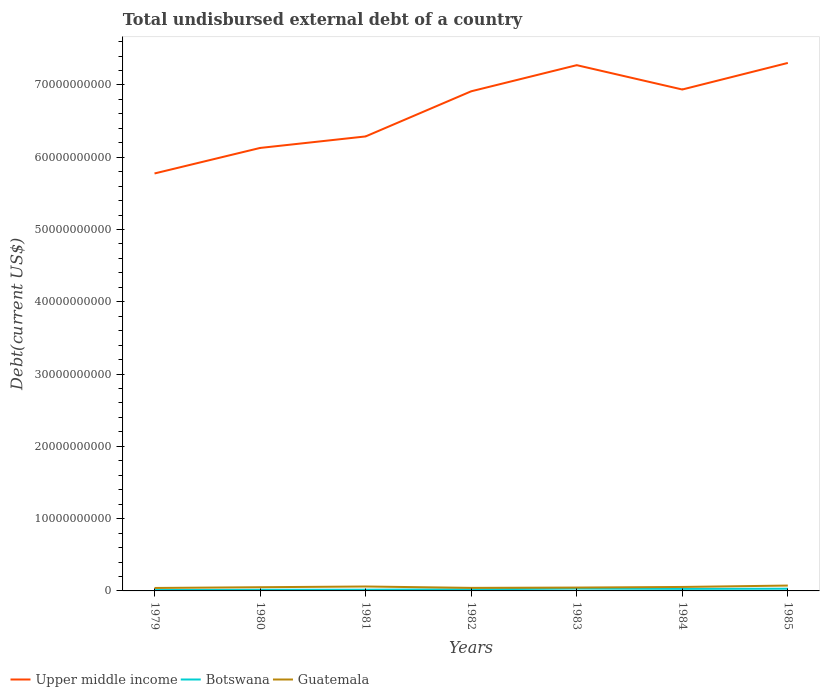How many different coloured lines are there?
Your answer should be very brief. 3. Does the line corresponding to Upper middle income intersect with the line corresponding to Guatemala?
Make the answer very short. No. Is the number of lines equal to the number of legend labels?
Your response must be concise. Yes. Across all years, what is the maximum total undisbursed external debt in Botswana?
Give a very brief answer. 1.18e+08. In which year was the total undisbursed external debt in Upper middle income maximum?
Your answer should be very brief. 1979. What is the total total undisbursed external debt in Upper middle income in the graph?
Provide a succinct answer. -1.02e+1. What is the difference between the highest and the second highest total undisbursed external debt in Guatemala?
Provide a succinct answer. 3.32e+08. What is the difference between the highest and the lowest total undisbursed external debt in Guatemala?
Offer a terse response. 3. Is the total undisbursed external debt in Botswana strictly greater than the total undisbursed external debt in Upper middle income over the years?
Your response must be concise. Yes. How many lines are there?
Your answer should be compact. 3. How many years are there in the graph?
Ensure brevity in your answer.  7. What is the difference between two consecutive major ticks on the Y-axis?
Your answer should be compact. 1.00e+1. Are the values on the major ticks of Y-axis written in scientific E-notation?
Provide a succinct answer. No. Does the graph contain grids?
Offer a very short reply. No. Where does the legend appear in the graph?
Give a very brief answer. Bottom left. How many legend labels are there?
Give a very brief answer. 3. How are the legend labels stacked?
Offer a terse response. Horizontal. What is the title of the graph?
Provide a succinct answer. Total undisbursed external debt of a country. Does "Fiji" appear as one of the legend labels in the graph?
Your answer should be very brief. No. What is the label or title of the Y-axis?
Your answer should be compact. Debt(current US$). What is the Debt(current US$) in Upper middle income in 1979?
Keep it short and to the point. 5.78e+1. What is the Debt(current US$) of Botswana in 1979?
Provide a succinct answer. 1.18e+08. What is the Debt(current US$) of Guatemala in 1979?
Offer a very short reply. 4.09e+08. What is the Debt(current US$) of Upper middle income in 1980?
Your answer should be very brief. 6.13e+1. What is the Debt(current US$) of Botswana in 1980?
Your answer should be very brief. 1.60e+08. What is the Debt(current US$) of Guatemala in 1980?
Keep it short and to the point. 5.12e+08. What is the Debt(current US$) in Upper middle income in 1981?
Offer a very short reply. 6.29e+1. What is the Debt(current US$) of Botswana in 1981?
Keep it short and to the point. 1.69e+08. What is the Debt(current US$) in Guatemala in 1981?
Give a very brief answer. 6.12e+08. What is the Debt(current US$) in Upper middle income in 1982?
Your answer should be very brief. 6.91e+1. What is the Debt(current US$) in Botswana in 1982?
Ensure brevity in your answer.  2.25e+08. What is the Debt(current US$) in Guatemala in 1982?
Offer a terse response. 4.22e+08. What is the Debt(current US$) of Upper middle income in 1983?
Provide a short and direct response. 7.27e+1. What is the Debt(current US$) of Botswana in 1983?
Your answer should be very brief. 3.24e+08. What is the Debt(current US$) in Guatemala in 1983?
Keep it short and to the point. 4.66e+08. What is the Debt(current US$) in Upper middle income in 1984?
Your answer should be very brief. 6.94e+1. What is the Debt(current US$) of Botswana in 1984?
Provide a succinct answer. 2.81e+08. What is the Debt(current US$) in Guatemala in 1984?
Your answer should be compact. 5.49e+08. What is the Debt(current US$) in Upper middle income in 1985?
Your answer should be very brief. 7.30e+1. What is the Debt(current US$) in Botswana in 1985?
Provide a succinct answer. 3.06e+08. What is the Debt(current US$) of Guatemala in 1985?
Provide a short and direct response. 7.41e+08. Across all years, what is the maximum Debt(current US$) of Upper middle income?
Keep it short and to the point. 7.30e+1. Across all years, what is the maximum Debt(current US$) of Botswana?
Give a very brief answer. 3.24e+08. Across all years, what is the maximum Debt(current US$) of Guatemala?
Your answer should be compact. 7.41e+08. Across all years, what is the minimum Debt(current US$) in Upper middle income?
Keep it short and to the point. 5.78e+1. Across all years, what is the minimum Debt(current US$) of Botswana?
Keep it short and to the point. 1.18e+08. Across all years, what is the minimum Debt(current US$) in Guatemala?
Offer a very short reply. 4.09e+08. What is the total Debt(current US$) in Upper middle income in the graph?
Provide a short and direct response. 4.66e+11. What is the total Debt(current US$) in Botswana in the graph?
Give a very brief answer. 1.58e+09. What is the total Debt(current US$) of Guatemala in the graph?
Offer a terse response. 3.71e+09. What is the difference between the Debt(current US$) in Upper middle income in 1979 and that in 1980?
Your answer should be very brief. -3.53e+09. What is the difference between the Debt(current US$) in Botswana in 1979 and that in 1980?
Keep it short and to the point. -4.16e+07. What is the difference between the Debt(current US$) in Guatemala in 1979 and that in 1980?
Your answer should be compact. -1.03e+08. What is the difference between the Debt(current US$) in Upper middle income in 1979 and that in 1981?
Give a very brief answer. -5.12e+09. What is the difference between the Debt(current US$) in Botswana in 1979 and that in 1981?
Your answer should be compact. -5.10e+07. What is the difference between the Debt(current US$) in Guatemala in 1979 and that in 1981?
Provide a succinct answer. -2.03e+08. What is the difference between the Debt(current US$) in Upper middle income in 1979 and that in 1982?
Make the answer very short. -1.14e+1. What is the difference between the Debt(current US$) in Botswana in 1979 and that in 1982?
Offer a terse response. -1.07e+08. What is the difference between the Debt(current US$) in Guatemala in 1979 and that in 1982?
Keep it short and to the point. -1.31e+07. What is the difference between the Debt(current US$) in Upper middle income in 1979 and that in 1983?
Provide a succinct answer. -1.50e+1. What is the difference between the Debt(current US$) of Botswana in 1979 and that in 1983?
Offer a terse response. -2.06e+08. What is the difference between the Debt(current US$) of Guatemala in 1979 and that in 1983?
Offer a very short reply. -5.65e+07. What is the difference between the Debt(current US$) in Upper middle income in 1979 and that in 1984?
Offer a terse response. -1.16e+1. What is the difference between the Debt(current US$) in Botswana in 1979 and that in 1984?
Your answer should be compact. -1.63e+08. What is the difference between the Debt(current US$) of Guatemala in 1979 and that in 1984?
Your answer should be very brief. -1.40e+08. What is the difference between the Debt(current US$) in Upper middle income in 1979 and that in 1985?
Your answer should be compact. -1.53e+1. What is the difference between the Debt(current US$) of Botswana in 1979 and that in 1985?
Offer a terse response. -1.88e+08. What is the difference between the Debt(current US$) of Guatemala in 1979 and that in 1985?
Ensure brevity in your answer.  -3.32e+08. What is the difference between the Debt(current US$) of Upper middle income in 1980 and that in 1981?
Offer a terse response. -1.59e+09. What is the difference between the Debt(current US$) in Botswana in 1980 and that in 1981?
Make the answer very short. -9.33e+06. What is the difference between the Debt(current US$) in Guatemala in 1980 and that in 1981?
Provide a succinct answer. -1.01e+08. What is the difference between the Debt(current US$) of Upper middle income in 1980 and that in 1982?
Your response must be concise. -7.84e+09. What is the difference between the Debt(current US$) of Botswana in 1980 and that in 1982?
Your answer should be compact. -6.54e+07. What is the difference between the Debt(current US$) of Guatemala in 1980 and that in 1982?
Make the answer very short. 8.94e+07. What is the difference between the Debt(current US$) in Upper middle income in 1980 and that in 1983?
Your answer should be compact. -1.15e+1. What is the difference between the Debt(current US$) of Botswana in 1980 and that in 1983?
Your answer should be compact. -1.65e+08. What is the difference between the Debt(current US$) in Guatemala in 1980 and that in 1983?
Give a very brief answer. 4.60e+07. What is the difference between the Debt(current US$) of Upper middle income in 1980 and that in 1984?
Provide a succinct answer. -8.09e+09. What is the difference between the Debt(current US$) of Botswana in 1980 and that in 1984?
Your answer should be very brief. -1.22e+08. What is the difference between the Debt(current US$) of Guatemala in 1980 and that in 1984?
Ensure brevity in your answer.  -3.72e+07. What is the difference between the Debt(current US$) of Upper middle income in 1980 and that in 1985?
Your answer should be compact. -1.18e+1. What is the difference between the Debt(current US$) of Botswana in 1980 and that in 1985?
Your answer should be compact. -1.46e+08. What is the difference between the Debt(current US$) in Guatemala in 1980 and that in 1985?
Your answer should be very brief. -2.30e+08. What is the difference between the Debt(current US$) of Upper middle income in 1981 and that in 1982?
Your answer should be very brief. -6.24e+09. What is the difference between the Debt(current US$) in Botswana in 1981 and that in 1982?
Your response must be concise. -5.61e+07. What is the difference between the Debt(current US$) in Guatemala in 1981 and that in 1982?
Keep it short and to the point. 1.90e+08. What is the difference between the Debt(current US$) of Upper middle income in 1981 and that in 1983?
Your response must be concise. -9.86e+09. What is the difference between the Debt(current US$) in Botswana in 1981 and that in 1983?
Offer a very short reply. -1.55e+08. What is the difference between the Debt(current US$) of Guatemala in 1981 and that in 1983?
Make the answer very short. 1.47e+08. What is the difference between the Debt(current US$) of Upper middle income in 1981 and that in 1984?
Your answer should be compact. -6.49e+09. What is the difference between the Debt(current US$) of Botswana in 1981 and that in 1984?
Make the answer very short. -1.12e+08. What is the difference between the Debt(current US$) in Guatemala in 1981 and that in 1984?
Offer a very short reply. 6.34e+07. What is the difference between the Debt(current US$) in Upper middle income in 1981 and that in 1985?
Provide a succinct answer. -1.02e+1. What is the difference between the Debt(current US$) in Botswana in 1981 and that in 1985?
Keep it short and to the point. -1.37e+08. What is the difference between the Debt(current US$) in Guatemala in 1981 and that in 1985?
Offer a very short reply. -1.29e+08. What is the difference between the Debt(current US$) in Upper middle income in 1982 and that in 1983?
Ensure brevity in your answer.  -3.62e+09. What is the difference between the Debt(current US$) of Botswana in 1982 and that in 1983?
Offer a very short reply. -9.93e+07. What is the difference between the Debt(current US$) of Guatemala in 1982 and that in 1983?
Keep it short and to the point. -4.34e+07. What is the difference between the Debt(current US$) of Upper middle income in 1982 and that in 1984?
Make the answer very short. -2.49e+08. What is the difference between the Debt(current US$) of Botswana in 1982 and that in 1984?
Give a very brief answer. -5.63e+07. What is the difference between the Debt(current US$) in Guatemala in 1982 and that in 1984?
Your answer should be compact. -1.27e+08. What is the difference between the Debt(current US$) in Upper middle income in 1982 and that in 1985?
Provide a succinct answer. -3.92e+09. What is the difference between the Debt(current US$) in Botswana in 1982 and that in 1985?
Offer a very short reply. -8.07e+07. What is the difference between the Debt(current US$) of Guatemala in 1982 and that in 1985?
Keep it short and to the point. -3.19e+08. What is the difference between the Debt(current US$) of Upper middle income in 1983 and that in 1984?
Make the answer very short. 3.37e+09. What is the difference between the Debt(current US$) in Botswana in 1983 and that in 1984?
Offer a very short reply. 4.31e+07. What is the difference between the Debt(current US$) in Guatemala in 1983 and that in 1984?
Offer a terse response. -8.32e+07. What is the difference between the Debt(current US$) in Upper middle income in 1983 and that in 1985?
Provide a succinct answer. -3.09e+08. What is the difference between the Debt(current US$) of Botswana in 1983 and that in 1985?
Offer a terse response. 1.86e+07. What is the difference between the Debt(current US$) in Guatemala in 1983 and that in 1985?
Provide a succinct answer. -2.76e+08. What is the difference between the Debt(current US$) in Upper middle income in 1984 and that in 1985?
Offer a terse response. -3.68e+09. What is the difference between the Debt(current US$) of Botswana in 1984 and that in 1985?
Offer a very short reply. -2.45e+07. What is the difference between the Debt(current US$) in Guatemala in 1984 and that in 1985?
Your answer should be very brief. -1.92e+08. What is the difference between the Debt(current US$) in Upper middle income in 1979 and the Debt(current US$) in Botswana in 1980?
Your answer should be very brief. 5.76e+1. What is the difference between the Debt(current US$) in Upper middle income in 1979 and the Debt(current US$) in Guatemala in 1980?
Provide a short and direct response. 5.72e+1. What is the difference between the Debt(current US$) in Botswana in 1979 and the Debt(current US$) in Guatemala in 1980?
Keep it short and to the point. -3.94e+08. What is the difference between the Debt(current US$) of Upper middle income in 1979 and the Debt(current US$) of Botswana in 1981?
Your answer should be compact. 5.76e+1. What is the difference between the Debt(current US$) in Upper middle income in 1979 and the Debt(current US$) in Guatemala in 1981?
Offer a very short reply. 5.71e+1. What is the difference between the Debt(current US$) of Botswana in 1979 and the Debt(current US$) of Guatemala in 1981?
Your response must be concise. -4.94e+08. What is the difference between the Debt(current US$) of Upper middle income in 1979 and the Debt(current US$) of Botswana in 1982?
Your answer should be compact. 5.75e+1. What is the difference between the Debt(current US$) in Upper middle income in 1979 and the Debt(current US$) in Guatemala in 1982?
Offer a very short reply. 5.73e+1. What is the difference between the Debt(current US$) in Botswana in 1979 and the Debt(current US$) in Guatemala in 1982?
Give a very brief answer. -3.04e+08. What is the difference between the Debt(current US$) of Upper middle income in 1979 and the Debt(current US$) of Botswana in 1983?
Provide a succinct answer. 5.74e+1. What is the difference between the Debt(current US$) of Upper middle income in 1979 and the Debt(current US$) of Guatemala in 1983?
Give a very brief answer. 5.73e+1. What is the difference between the Debt(current US$) of Botswana in 1979 and the Debt(current US$) of Guatemala in 1983?
Keep it short and to the point. -3.48e+08. What is the difference between the Debt(current US$) of Upper middle income in 1979 and the Debt(current US$) of Botswana in 1984?
Your answer should be compact. 5.75e+1. What is the difference between the Debt(current US$) of Upper middle income in 1979 and the Debt(current US$) of Guatemala in 1984?
Offer a terse response. 5.72e+1. What is the difference between the Debt(current US$) of Botswana in 1979 and the Debt(current US$) of Guatemala in 1984?
Your answer should be compact. -4.31e+08. What is the difference between the Debt(current US$) in Upper middle income in 1979 and the Debt(current US$) in Botswana in 1985?
Provide a succinct answer. 5.74e+1. What is the difference between the Debt(current US$) of Upper middle income in 1979 and the Debt(current US$) of Guatemala in 1985?
Provide a succinct answer. 5.70e+1. What is the difference between the Debt(current US$) in Botswana in 1979 and the Debt(current US$) in Guatemala in 1985?
Make the answer very short. -6.23e+08. What is the difference between the Debt(current US$) in Upper middle income in 1980 and the Debt(current US$) in Botswana in 1981?
Your answer should be compact. 6.11e+1. What is the difference between the Debt(current US$) of Upper middle income in 1980 and the Debt(current US$) of Guatemala in 1981?
Offer a terse response. 6.07e+1. What is the difference between the Debt(current US$) of Botswana in 1980 and the Debt(current US$) of Guatemala in 1981?
Your answer should be compact. -4.53e+08. What is the difference between the Debt(current US$) in Upper middle income in 1980 and the Debt(current US$) in Botswana in 1982?
Keep it short and to the point. 6.11e+1. What is the difference between the Debt(current US$) in Upper middle income in 1980 and the Debt(current US$) in Guatemala in 1982?
Your answer should be compact. 6.09e+1. What is the difference between the Debt(current US$) in Botswana in 1980 and the Debt(current US$) in Guatemala in 1982?
Your answer should be very brief. -2.63e+08. What is the difference between the Debt(current US$) of Upper middle income in 1980 and the Debt(current US$) of Botswana in 1983?
Make the answer very short. 6.10e+1. What is the difference between the Debt(current US$) in Upper middle income in 1980 and the Debt(current US$) in Guatemala in 1983?
Your answer should be compact. 6.08e+1. What is the difference between the Debt(current US$) of Botswana in 1980 and the Debt(current US$) of Guatemala in 1983?
Your answer should be compact. -3.06e+08. What is the difference between the Debt(current US$) of Upper middle income in 1980 and the Debt(current US$) of Botswana in 1984?
Your answer should be very brief. 6.10e+1. What is the difference between the Debt(current US$) of Upper middle income in 1980 and the Debt(current US$) of Guatemala in 1984?
Offer a terse response. 6.07e+1. What is the difference between the Debt(current US$) in Botswana in 1980 and the Debt(current US$) in Guatemala in 1984?
Provide a succinct answer. -3.89e+08. What is the difference between the Debt(current US$) of Upper middle income in 1980 and the Debt(current US$) of Botswana in 1985?
Make the answer very short. 6.10e+1. What is the difference between the Debt(current US$) of Upper middle income in 1980 and the Debt(current US$) of Guatemala in 1985?
Give a very brief answer. 6.05e+1. What is the difference between the Debt(current US$) of Botswana in 1980 and the Debt(current US$) of Guatemala in 1985?
Offer a very short reply. -5.82e+08. What is the difference between the Debt(current US$) in Upper middle income in 1981 and the Debt(current US$) in Botswana in 1982?
Offer a very short reply. 6.27e+1. What is the difference between the Debt(current US$) in Upper middle income in 1981 and the Debt(current US$) in Guatemala in 1982?
Your response must be concise. 6.25e+1. What is the difference between the Debt(current US$) in Botswana in 1981 and the Debt(current US$) in Guatemala in 1982?
Your answer should be compact. -2.53e+08. What is the difference between the Debt(current US$) of Upper middle income in 1981 and the Debt(current US$) of Botswana in 1983?
Make the answer very short. 6.26e+1. What is the difference between the Debt(current US$) of Upper middle income in 1981 and the Debt(current US$) of Guatemala in 1983?
Make the answer very short. 6.24e+1. What is the difference between the Debt(current US$) in Botswana in 1981 and the Debt(current US$) in Guatemala in 1983?
Make the answer very short. -2.97e+08. What is the difference between the Debt(current US$) of Upper middle income in 1981 and the Debt(current US$) of Botswana in 1984?
Keep it short and to the point. 6.26e+1. What is the difference between the Debt(current US$) in Upper middle income in 1981 and the Debt(current US$) in Guatemala in 1984?
Ensure brevity in your answer.  6.23e+1. What is the difference between the Debt(current US$) of Botswana in 1981 and the Debt(current US$) of Guatemala in 1984?
Provide a short and direct response. -3.80e+08. What is the difference between the Debt(current US$) in Upper middle income in 1981 and the Debt(current US$) in Botswana in 1985?
Your answer should be compact. 6.26e+1. What is the difference between the Debt(current US$) in Upper middle income in 1981 and the Debt(current US$) in Guatemala in 1985?
Ensure brevity in your answer.  6.21e+1. What is the difference between the Debt(current US$) of Botswana in 1981 and the Debt(current US$) of Guatemala in 1985?
Provide a succinct answer. -5.72e+08. What is the difference between the Debt(current US$) of Upper middle income in 1982 and the Debt(current US$) of Botswana in 1983?
Offer a terse response. 6.88e+1. What is the difference between the Debt(current US$) of Upper middle income in 1982 and the Debt(current US$) of Guatemala in 1983?
Offer a very short reply. 6.87e+1. What is the difference between the Debt(current US$) in Botswana in 1982 and the Debt(current US$) in Guatemala in 1983?
Give a very brief answer. -2.41e+08. What is the difference between the Debt(current US$) in Upper middle income in 1982 and the Debt(current US$) in Botswana in 1984?
Your answer should be compact. 6.88e+1. What is the difference between the Debt(current US$) of Upper middle income in 1982 and the Debt(current US$) of Guatemala in 1984?
Your answer should be very brief. 6.86e+1. What is the difference between the Debt(current US$) of Botswana in 1982 and the Debt(current US$) of Guatemala in 1984?
Provide a short and direct response. -3.24e+08. What is the difference between the Debt(current US$) of Upper middle income in 1982 and the Debt(current US$) of Botswana in 1985?
Give a very brief answer. 6.88e+1. What is the difference between the Debt(current US$) of Upper middle income in 1982 and the Debt(current US$) of Guatemala in 1985?
Make the answer very short. 6.84e+1. What is the difference between the Debt(current US$) in Botswana in 1982 and the Debt(current US$) in Guatemala in 1985?
Offer a very short reply. -5.16e+08. What is the difference between the Debt(current US$) in Upper middle income in 1983 and the Debt(current US$) in Botswana in 1984?
Offer a very short reply. 7.25e+1. What is the difference between the Debt(current US$) of Upper middle income in 1983 and the Debt(current US$) of Guatemala in 1984?
Make the answer very short. 7.22e+1. What is the difference between the Debt(current US$) of Botswana in 1983 and the Debt(current US$) of Guatemala in 1984?
Provide a succinct answer. -2.24e+08. What is the difference between the Debt(current US$) of Upper middle income in 1983 and the Debt(current US$) of Botswana in 1985?
Make the answer very short. 7.24e+1. What is the difference between the Debt(current US$) in Upper middle income in 1983 and the Debt(current US$) in Guatemala in 1985?
Offer a terse response. 7.20e+1. What is the difference between the Debt(current US$) of Botswana in 1983 and the Debt(current US$) of Guatemala in 1985?
Give a very brief answer. -4.17e+08. What is the difference between the Debt(current US$) of Upper middle income in 1984 and the Debt(current US$) of Botswana in 1985?
Ensure brevity in your answer.  6.91e+1. What is the difference between the Debt(current US$) of Upper middle income in 1984 and the Debt(current US$) of Guatemala in 1985?
Ensure brevity in your answer.  6.86e+1. What is the difference between the Debt(current US$) in Botswana in 1984 and the Debt(current US$) in Guatemala in 1985?
Your response must be concise. -4.60e+08. What is the average Debt(current US$) in Upper middle income per year?
Your answer should be compact. 6.66e+1. What is the average Debt(current US$) of Botswana per year?
Keep it short and to the point. 2.26e+08. What is the average Debt(current US$) in Guatemala per year?
Give a very brief answer. 5.30e+08. In the year 1979, what is the difference between the Debt(current US$) of Upper middle income and Debt(current US$) of Botswana?
Offer a very short reply. 5.76e+1. In the year 1979, what is the difference between the Debt(current US$) of Upper middle income and Debt(current US$) of Guatemala?
Your answer should be compact. 5.73e+1. In the year 1979, what is the difference between the Debt(current US$) of Botswana and Debt(current US$) of Guatemala?
Your response must be concise. -2.91e+08. In the year 1980, what is the difference between the Debt(current US$) in Upper middle income and Debt(current US$) in Botswana?
Your answer should be very brief. 6.11e+1. In the year 1980, what is the difference between the Debt(current US$) in Upper middle income and Debt(current US$) in Guatemala?
Your response must be concise. 6.08e+1. In the year 1980, what is the difference between the Debt(current US$) of Botswana and Debt(current US$) of Guatemala?
Provide a short and direct response. -3.52e+08. In the year 1981, what is the difference between the Debt(current US$) of Upper middle income and Debt(current US$) of Botswana?
Give a very brief answer. 6.27e+1. In the year 1981, what is the difference between the Debt(current US$) in Upper middle income and Debt(current US$) in Guatemala?
Keep it short and to the point. 6.23e+1. In the year 1981, what is the difference between the Debt(current US$) in Botswana and Debt(current US$) in Guatemala?
Give a very brief answer. -4.43e+08. In the year 1982, what is the difference between the Debt(current US$) of Upper middle income and Debt(current US$) of Botswana?
Keep it short and to the point. 6.89e+1. In the year 1982, what is the difference between the Debt(current US$) in Upper middle income and Debt(current US$) in Guatemala?
Your answer should be compact. 6.87e+1. In the year 1982, what is the difference between the Debt(current US$) in Botswana and Debt(current US$) in Guatemala?
Offer a very short reply. -1.97e+08. In the year 1983, what is the difference between the Debt(current US$) of Upper middle income and Debt(current US$) of Botswana?
Ensure brevity in your answer.  7.24e+1. In the year 1983, what is the difference between the Debt(current US$) in Upper middle income and Debt(current US$) in Guatemala?
Your response must be concise. 7.23e+1. In the year 1983, what is the difference between the Debt(current US$) of Botswana and Debt(current US$) of Guatemala?
Make the answer very short. -1.41e+08. In the year 1984, what is the difference between the Debt(current US$) of Upper middle income and Debt(current US$) of Botswana?
Ensure brevity in your answer.  6.91e+1. In the year 1984, what is the difference between the Debt(current US$) of Upper middle income and Debt(current US$) of Guatemala?
Your answer should be very brief. 6.88e+1. In the year 1984, what is the difference between the Debt(current US$) in Botswana and Debt(current US$) in Guatemala?
Your answer should be compact. -2.67e+08. In the year 1985, what is the difference between the Debt(current US$) of Upper middle income and Debt(current US$) of Botswana?
Your answer should be very brief. 7.27e+1. In the year 1985, what is the difference between the Debt(current US$) of Upper middle income and Debt(current US$) of Guatemala?
Provide a short and direct response. 7.23e+1. In the year 1985, what is the difference between the Debt(current US$) in Botswana and Debt(current US$) in Guatemala?
Make the answer very short. -4.35e+08. What is the ratio of the Debt(current US$) in Upper middle income in 1979 to that in 1980?
Offer a terse response. 0.94. What is the ratio of the Debt(current US$) in Botswana in 1979 to that in 1980?
Offer a very short reply. 0.74. What is the ratio of the Debt(current US$) of Guatemala in 1979 to that in 1980?
Ensure brevity in your answer.  0.8. What is the ratio of the Debt(current US$) of Upper middle income in 1979 to that in 1981?
Offer a very short reply. 0.92. What is the ratio of the Debt(current US$) of Botswana in 1979 to that in 1981?
Ensure brevity in your answer.  0.7. What is the ratio of the Debt(current US$) of Guatemala in 1979 to that in 1981?
Provide a succinct answer. 0.67. What is the ratio of the Debt(current US$) in Upper middle income in 1979 to that in 1982?
Offer a very short reply. 0.84. What is the ratio of the Debt(current US$) in Botswana in 1979 to that in 1982?
Your response must be concise. 0.52. What is the ratio of the Debt(current US$) in Guatemala in 1979 to that in 1982?
Provide a succinct answer. 0.97. What is the ratio of the Debt(current US$) in Upper middle income in 1979 to that in 1983?
Ensure brevity in your answer.  0.79. What is the ratio of the Debt(current US$) of Botswana in 1979 to that in 1983?
Provide a succinct answer. 0.36. What is the ratio of the Debt(current US$) of Guatemala in 1979 to that in 1983?
Offer a terse response. 0.88. What is the ratio of the Debt(current US$) in Upper middle income in 1979 to that in 1984?
Keep it short and to the point. 0.83. What is the ratio of the Debt(current US$) in Botswana in 1979 to that in 1984?
Offer a very short reply. 0.42. What is the ratio of the Debt(current US$) of Guatemala in 1979 to that in 1984?
Provide a short and direct response. 0.75. What is the ratio of the Debt(current US$) in Upper middle income in 1979 to that in 1985?
Your response must be concise. 0.79. What is the ratio of the Debt(current US$) of Botswana in 1979 to that in 1985?
Provide a succinct answer. 0.39. What is the ratio of the Debt(current US$) of Guatemala in 1979 to that in 1985?
Ensure brevity in your answer.  0.55. What is the ratio of the Debt(current US$) in Upper middle income in 1980 to that in 1981?
Your response must be concise. 0.97. What is the ratio of the Debt(current US$) in Botswana in 1980 to that in 1981?
Provide a succinct answer. 0.94. What is the ratio of the Debt(current US$) of Guatemala in 1980 to that in 1981?
Make the answer very short. 0.84. What is the ratio of the Debt(current US$) of Upper middle income in 1980 to that in 1982?
Keep it short and to the point. 0.89. What is the ratio of the Debt(current US$) of Botswana in 1980 to that in 1982?
Ensure brevity in your answer.  0.71. What is the ratio of the Debt(current US$) of Guatemala in 1980 to that in 1982?
Offer a terse response. 1.21. What is the ratio of the Debt(current US$) in Upper middle income in 1980 to that in 1983?
Offer a terse response. 0.84. What is the ratio of the Debt(current US$) of Botswana in 1980 to that in 1983?
Your response must be concise. 0.49. What is the ratio of the Debt(current US$) in Guatemala in 1980 to that in 1983?
Your answer should be very brief. 1.1. What is the ratio of the Debt(current US$) of Upper middle income in 1980 to that in 1984?
Make the answer very short. 0.88. What is the ratio of the Debt(current US$) of Botswana in 1980 to that in 1984?
Provide a short and direct response. 0.57. What is the ratio of the Debt(current US$) of Guatemala in 1980 to that in 1984?
Give a very brief answer. 0.93. What is the ratio of the Debt(current US$) in Upper middle income in 1980 to that in 1985?
Your response must be concise. 0.84. What is the ratio of the Debt(current US$) in Botswana in 1980 to that in 1985?
Your answer should be compact. 0.52. What is the ratio of the Debt(current US$) in Guatemala in 1980 to that in 1985?
Your answer should be compact. 0.69. What is the ratio of the Debt(current US$) in Upper middle income in 1981 to that in 1982?
Provide a short and direct response. 0.91. What is the ratio of the Debt(current US$) in Botswana in 1981 to that in 1982?
Ensure brevity in your answer.  0.75. What is the ratio of the Debt(current US$) of Guatemala in 1981 to that in 1982?
Your answer should be compact. 1.45. What is the ratio of the Debt(current US$) of Upper middle income in 1981 to that in 1983?
Offer a terse response. 0.86. What is the ratio of the Debt(current US$) in Botswana in 1981 to that in 1983?
Provide a short and direct response. 0.52. What is the ratio of the Debt(current US$) of Guatemala in 1981 to that in 1983?
Your answer should be compact. 1.31. What is the ratio of the Debt(current US$) of Upper middle income in 1981 to that in 1984?
Your answer should be compact. 0.91. What is the ratio of the Debt(current US$) of Botswana in 1981 to that in 1984?
Keep it short and to the point. 0.6. What is the ratio of the Debt(current US$) in Guatemala in 1981 to that in 1984?
Offer a very short reply. 1.12. What is the ratio of the Debt(current US$) in Upper middle income in 1981 to that in 1985?
Your answer should be very brief. 0.86. What is the ratio of the Debt(current US$) of Botswana in 1981 to that in 1985?
Your answer should be compact. 0.55. What is the ratio of the Debt(current US$) of Guatemala in 1981 to that in 1985?
Your answer should be compact. 0.83. What is the ratio of the Debt(current US$) in Upper middle income in 1982 to that in 1983?
Provide a succinct answer. 0.95. What is the ratio of the Debt(current US$) in Botswana in 1982 to that in 1983?
Your answer should be very brief. 0.69. What is the ratio of the Debt(current US$) of Guatemala in 1982 to that in 1983?
Your response must be concise. 0.91. What is the ratio of the Debt(current US$) in Botswana in 1982 to that in 1984?
Offer a terse response. 0.8. What is the ratio of the Debt(current US$) of Guatemala in 1982 to that in 1984?
Offer a very short reply. 0.77. What is the ratio of the Debt(current US$) in Upper middle income in 1982 to that in 1985?
Your answer should be very brief. 0.95. What is the ratio of the Debt(current US$) of Botswana in 1982 to that in 1985?
Your answer should be compact. 0.74. What is the ratio of the Debt(current US$) in Guatemala in 1982 to that in 1985?
Give a very brief answer. 0.57. What is the ratio of the Debt(current US$) in Upper middle income in 1983 to that in 1984?
Your answer should be very brief. 1.05. What is the ratio of the Debt(current US$) in Botswana in 1983 to that in 1984?
Provide a succinct answer. 1.15. What is the ratio of the Debt(current US$) in Guatemala in 1983 to that in 1984?
Keep it short and to the point. 0.85. What is the ratio of the Debt(current US$) in Upper middle income in 1983 to that in 1985?
Provide a succinct answer. 1. What is the ratio of the Debt(current US$) of Botswana in 1983 to that in 1985?
Offer a very short reply. 1.06. What is the ratio of the Debt(current US$) of Guatemala in 1983 to that in 1985?
Provide a short and direct response. 0.63. What is the ratio of the Debt(current US$) in Upper middle income in 1984 to that in 1985?
Offer a terse response. 0.95. What is the ratio of the Debt(current US$) of Guatemala in 1984 to that in 1985?
Keep it short and to the point. 0.74. What is the difference between the highest and the second highest Debt(current US$) in Upper middle income?
Give a very brief answer. 3.09e+08. What is the difference between the highest and the second highest Debt(current US$) in Botswana?
Offer a terse response. 1.86e+07. What is the difference between the highest and the second highest Debt(current US$) in Guatemala?
Your response must be concise. 1.29e+08. What is the difference between the highest and the lowest Debt(current US$) in Upper middle income?
Provide a short and direct response. 1.53e+1. What is the difference between the highest and the lowest Debt(current US$) of Botswana?
Offer a very short reply. 2.06e+08. What is the difference between the highest and the lowest Debt(current US$) in Guatemala?
Your answer should be compact. 3.32e+08. 